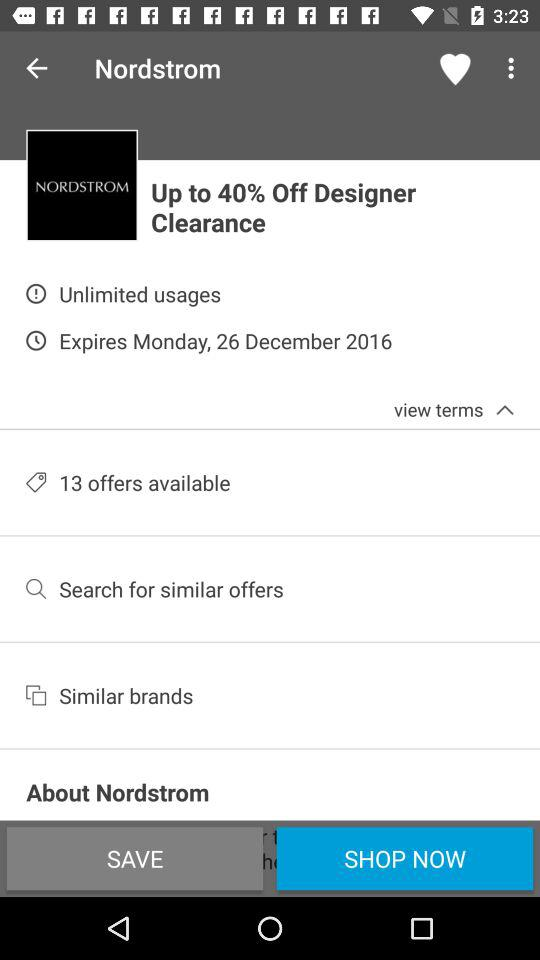How much is the discount? The discount is up to 40%. 